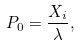<formula> <loc_0><loc_0><loc_500><loc_500>P _ { 0 } = \frac { X _ { i } } { \lambda } ,</formula> 